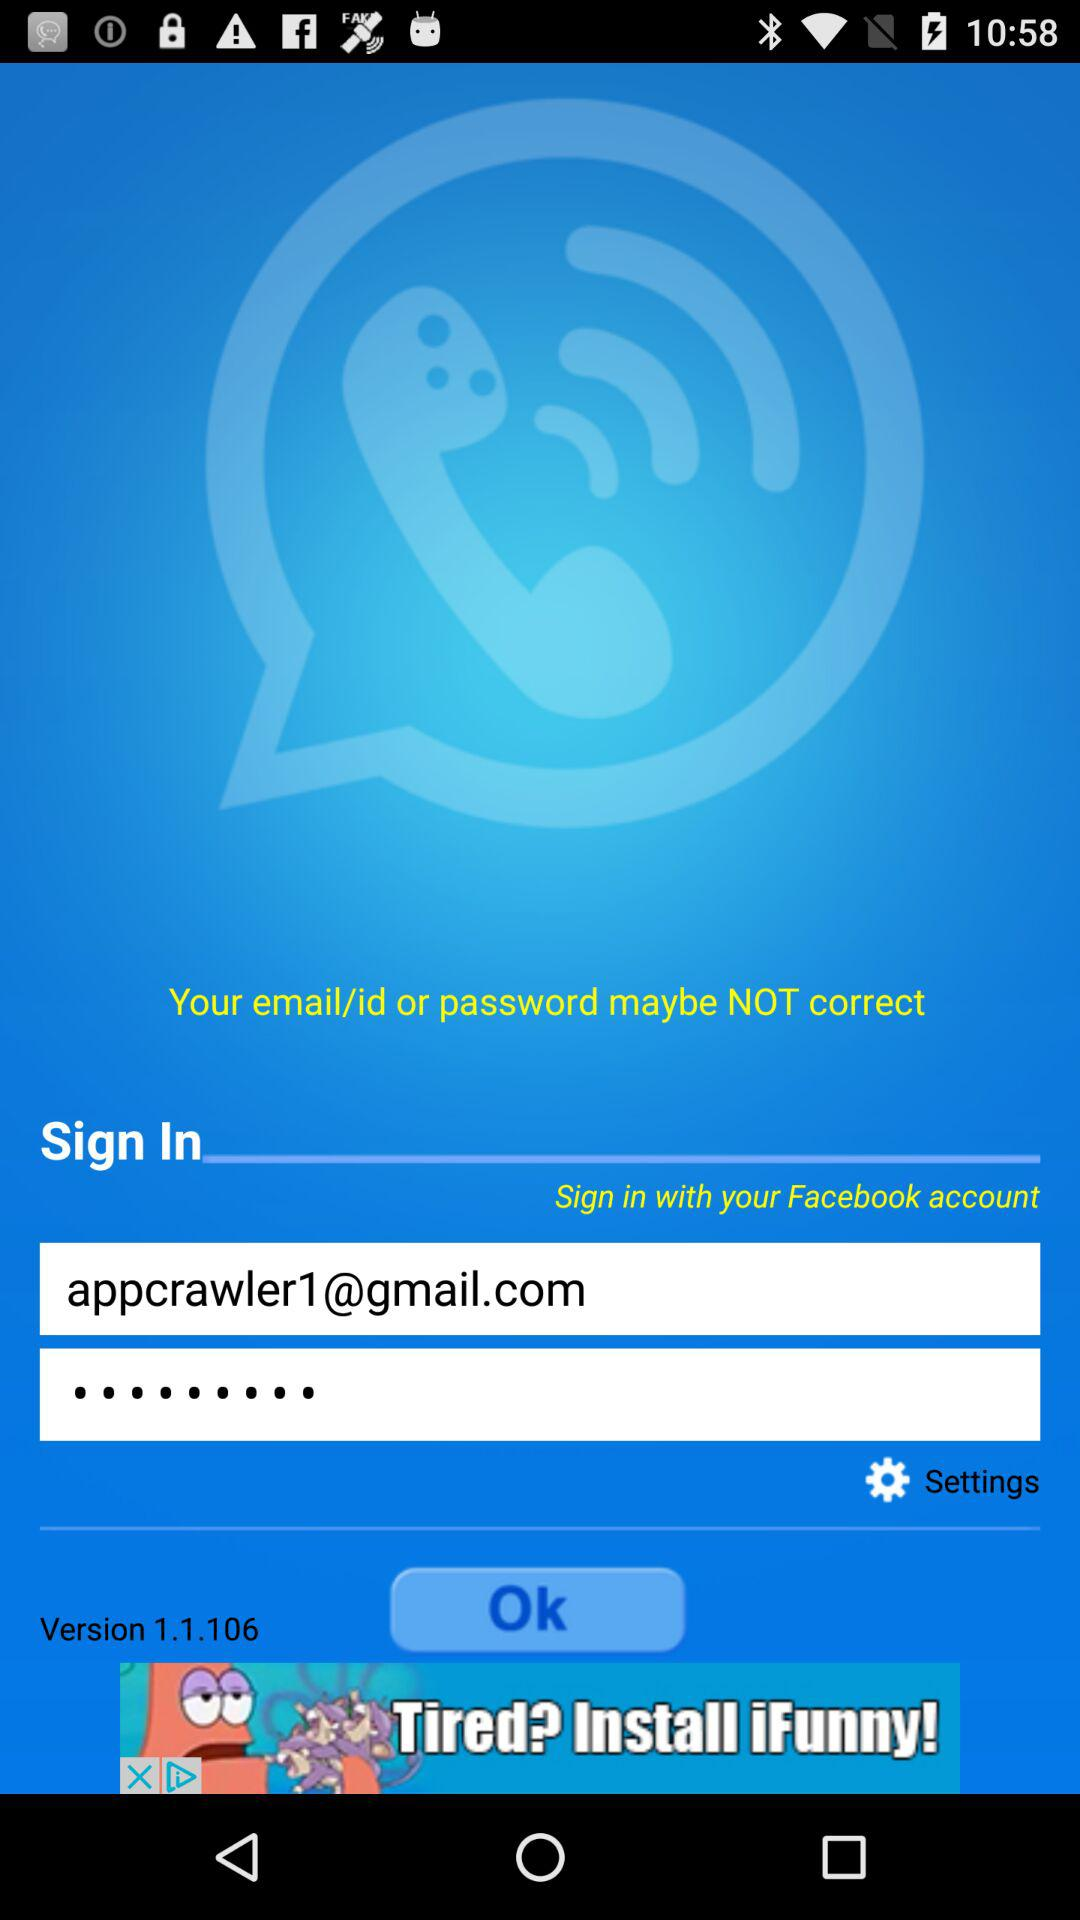What is the version of the app? The version of the app is 1.1.106. 